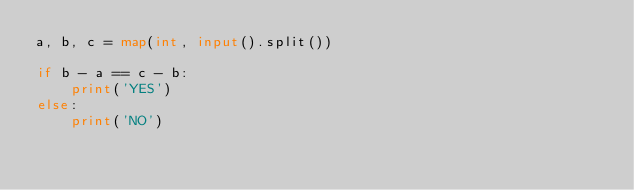Convert code to text. <code><loc_0><loc_0><loc_500><loc_500><_Python_>a, b, c = map(int, input().split())

if b - a == c - b:
    print('YES')
else:
    print('NO')
</code> 